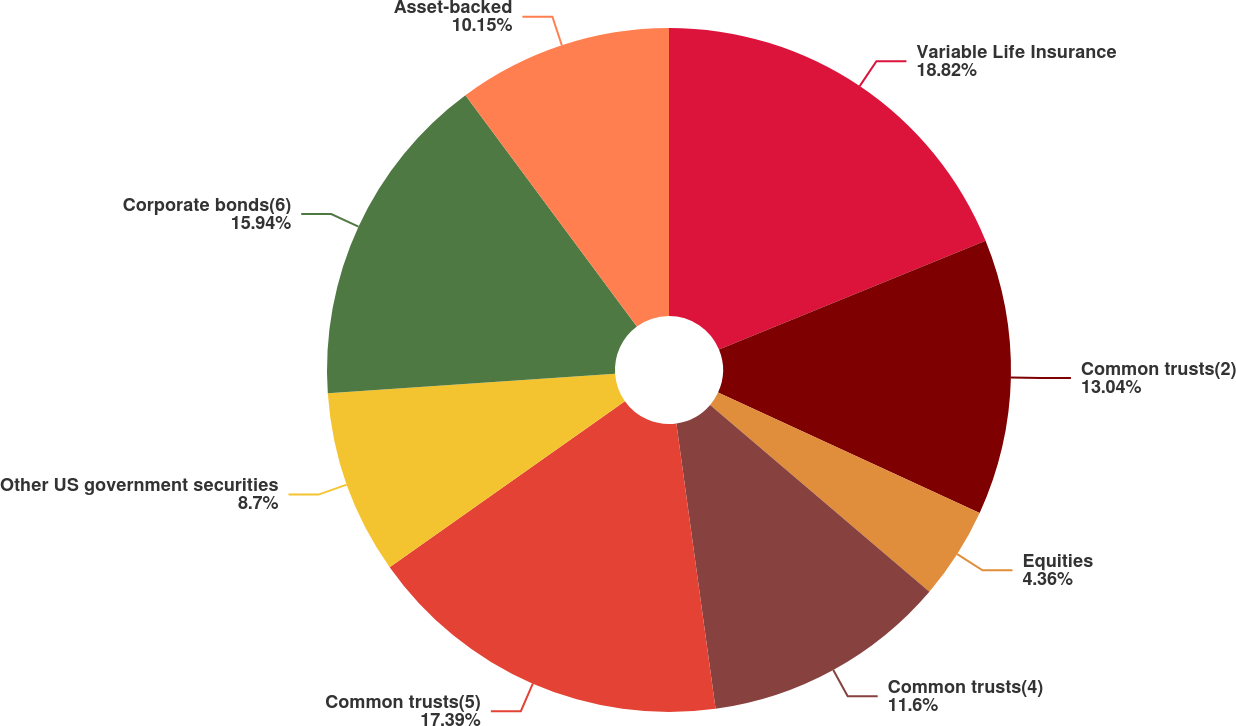<chart> <loc_0><loc_0><loc_500><loc_500><pie_chart><fcel>Variable Life Insurance<fcel>Common trusts(2)<fcel>Equities<fcel>Common trusts(4)<fcel>Common trusts(5)<fcel>Other US government securities<fcel>Corporate bonds(6)<fcel>Asset-backed<nl><fcel>18.83%<fcel>13.04%<fcel>4.36%<fcel>11.6%<fcel>17.39%<fcel>8.7%<fcel>15.94%<fcel>10.15%<nl></chart> 